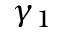Convert formula to latex. <formula><loc_0><loc_0><loc_500><loc_500>\gamma _ { 1 }</formula> 